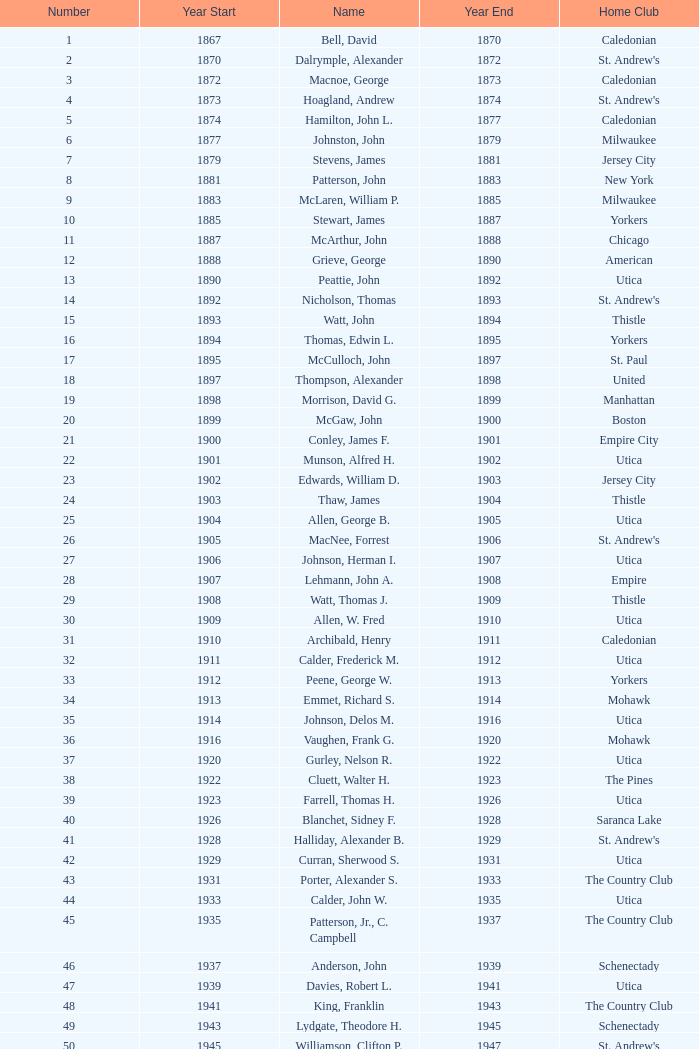Could you parse the entire table? {'header': ['Number', 'Year Start', 'Name', 'Year End', 'Home Club'], 'rows': [['1', '1867', 'Bell, David', '1870', 'Caledonian'], ['2', '1870', 'Dalrymple, Alexander', '1872', "St. Andrew's"], ['3', '1872', 'Macnoe, George', '1873', 'Caledonian'], ['4', '1873', 'Hoagland, Andrew', '1874', "St. Andrew's"], ['5', '1874', 'Hamilton, John L.', '1877', 'Caledonian'], ['6', '1877', 'Johnston, John', '1879', 'Milwaukee'], ['7', '1879', 'Stevens, James', '1881', 'Jersey City'], ['8', '1881', 'Patterson, John', '1883', 'New York'], ['9', '1883', 'McLaren, William P.', '1885', 'Milwaukee'], ['10', '1885', 'Stewart, James', '1887', 'Yorkers'], ['11', '1887', 'McArthur, John', '1888', 'Chicago'], ['12', '1888', 'Grieve, George', '1890', 'American'], ['13', '1890', 'Peattie, John', '1892', 'Utica'], ['14', '1892', 'Nicholson, Thomas', '1893', "St. Andrew's"], ['15', '1893', 'Watt, John', '1894', 'Thistle'], ['16', '1894', 'Thomas, Edwin L.', '1895', 'Yorkers'], ['17', '1895', 'McCulloch, John', '1897', 'St. Paul'], ['18', '1897', 'Thompson, Alexander', '1898', 'United'], ['19', '1898', 'Morrison, David G.', '1899', 'Manhattan'], ['20', '1899', 'McGaw, John', '1900', 'Boston'], ['21', '1900', 'Conley, James F.', '1901', 'Empire City'], ['22', '1901', 'Munson, Alfred H.', '1902', 'Utica'], ['23', '1902', 'Edwards, William D.', '1903', 'Jersey City'], ['24', '1903', 'Thaw, James', '1904', 'Thistle'], ['25', '1904', 'Allen, George B.', '1905', 'Utica'], ['26', '1905', 'MacNee, Forrest', '1906', "St. Andrew's"], ['27', '1906', 'Johnson, Herman I.', '1907', 'Utica'], ['28', '1907', 'Lehmann, John A.', '1908', 'Empire'], ['29', '1908', 'Watt, Thomas J.', '1909', 'Thistle'], ['30', '1909', 'Allen, W. Fred', '1910', 'Utica'], ['31', '1910', 'Archibald, Henry', '1911', 'Caledonian'], ['32', '1911', 'Calder, Frederick M.', '1912', 'Utica'], ['33', '1912', 'Peene, George W.', '1913', 'Yorkers'], ['34', '1913', 'Emmet, Richard S.', '1914', 'Mohawk'], ['35', '1914', 'Johnson, Delos M.', '1916', 'Utica'], ['36', '1916', 'Vaughen, Frank G.', '1920', 'Mohawk'], ['37', '1920', 'Gurley, Nelson R.', '1922', 'Utica'], ['38', '1922', 'Cluett, Walter H.', '1923', 'The Pines'], ['39', '1923', 'Farrell, Thomas H.', '1926', 'Utica'], ['40', '1926', 'Blanchet, Sidney F.', '1928', 'Saranca Lake'], ['41', '1928', 'Halliday, Alexander B.', '1929', "St. Andrew's"], ['42', '1929', 'Curran, Sherwood S.', '1931', 'Utica'], ['43', '1931', 'Porter, Alexander S.', '1933', 'The Country Club'], ['44', '1933', 'Calder, John W.', '1935', 'Utica'], ['45', '1935', 'Patterson, Jr., C. Campbell', '1937', 'The Country Club'], ['46', '1937', 'Anderson, John', '1939', 'Schenectady'], ['47', '1939', 'Davies, Robert L.', '1941', 'Utica'], ['48', '1941', 'King, Franklin', '1943', 'The Country Club'], ['49', '1943', 'Lydgate, Theodore H.', '1945', 'Schenectady'], ['50', '1945', 'Williamson, Clifton P.', '1947', "St. Andrew's"], ['51', '1947', 'Hurd, Kenneth S.', '1949', 'Utica'], ['52', '1949', 'Hastings, Addison B.', '1951', 'Ardsley'], ['53', '1951', 'Hill, Lucius T.', '1953', 'The Country Club'], ['54', '1953', 'Davis, Richard P.', '1954', 'Schenectady'], ['55', '1954', 'Joy, John H.', '1956', 'Winchester'], ['56', '1956', 'Searle, William A.', '1957', 'Utica'], ['57', '1957', 'Smith, Dr. Deering G.', '1958', 'Nashua'], ['58', '1958', 'Seibert, W. Lincoln', '1959', "St. Andrew's"], ['59', '1959', 'Reid, Ralston B.', '1961', 'Schenectady'], ['60', '1961', 'Cushing, Henry K.', '1963', 'The Country Club'], ['61', '1963', 'Wood, Brenner R.', '1965', 'Ardsley'], ['62', '1965', 'Parkinson, Fred E.', '1966', 'Utica'], ['63', '1966', 'Childs, Edward C.', '1968', 'Norfolk'], ['64', '1968', 'Rand, Grenfell N.', '1970', 'Albany'], ['65', '1970', 'Neill, Stanley E.', '1972', 'Winchester'], ['66', '1972', 'Milano, Dr. Joseph E.', '1974', 'NY Caledonian'], ['67', '1974', 'Neuber, Dr. Richard A.', '1976', 'Schenectady'], ['68', '1976', 'Cobb, Arthur J.', '1978', 'Utica'], ['69', '1978', 'Hamm, Arthur E.', '1980', 'Petersham'], ['70', '1980', 'Will, A. Roland', '1982', 'Nutmeg'], ['71', '1982', 'Cooper, C. Kenneth', '1984', 'NY Caledonian'], ['72', '1984', 'Porter, David R.', '1986', 'Wellesley'], ['73', '1984', 'Millington, A. Wesley', '1986', 'Schenectady'], ['74', '1988', 'Dewees, Dr. David C.', '1989', 'Cape Cod'], ['75', '1989', 'Owens, Charles D.', '1991', 'Nutmeg'], ['76', '1991', 'Mitchell, J. Peter', '1993', 'Garden State'], ['77', '1993', 'Lopez, Jr., Chester H.', '1995', 'Nashua'], ['78', '1995', 'Freeman, Kim', '1997', 'Schenectady'], ['79', '1997', 'Williams, Samuel C.', '1999', 'Broomstones'], ['80', '1999', 'Hatch, Peggy', '2001', 'Philadelphia'], ['81', '2001', 'Garber, Thomas', '2003', 'Utica'], ['82', '2003', 'Pelletier, Robert', '2005', 'Potomac'], ['83', '2005', 'Chandler, Robert P.', '2007', 'Broomstones'], ['84', '2007', 'Krailo, Gwen', '2009', 'Nashua'], ['85', '2009', 'Thomas, Carl', '2011', 'Utica'], ['86', '2011', 'Macartney, Dick', '2013', 'Coastal Carolina']]} Which Number has a Year Start smaller than 1874, and a Year End larger than 1873? 4.0. 